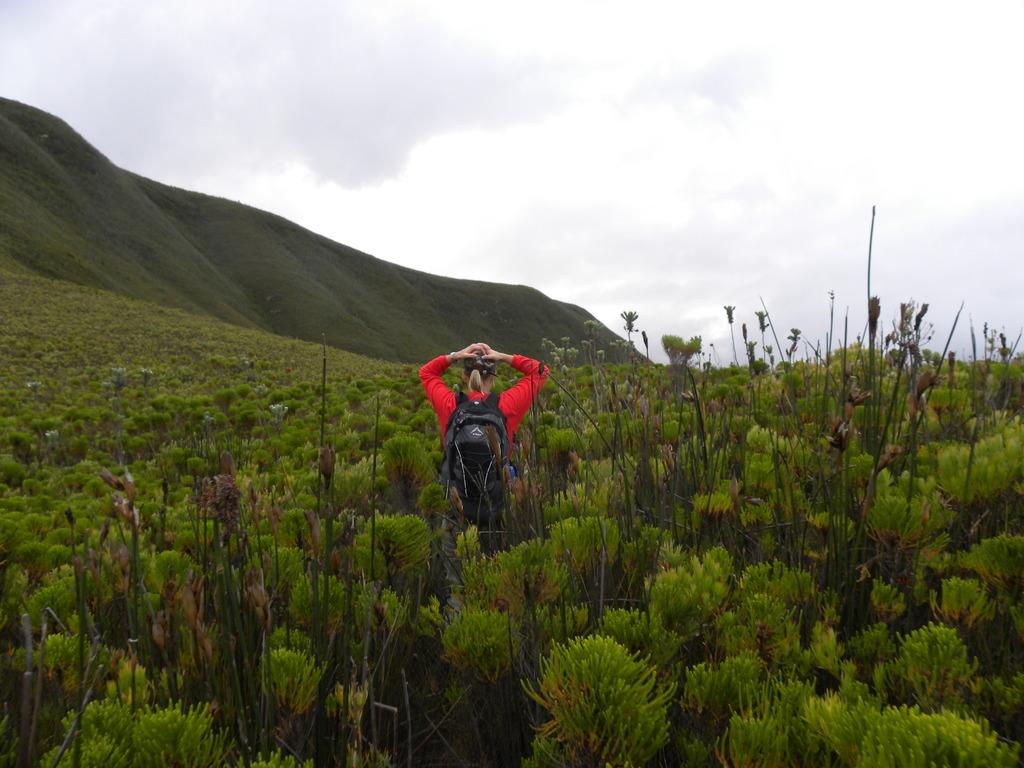What type of living organisms can be seen in the image? Plants can be seen in the image. Where is the person located in the image? The person is standing in the middle of the image. What can be seen in the sky in the image? Clouds and the sky are visible in the image. What type of natural landscape is visible in the image? Hills are visible in the image. How many kittens are playing with a ticket in the image? There are no kittens or tickets present in the image. What is the person's temper like in the image? The person's temper cannot be determined from the image, as it does not show any emotions or expressions. 